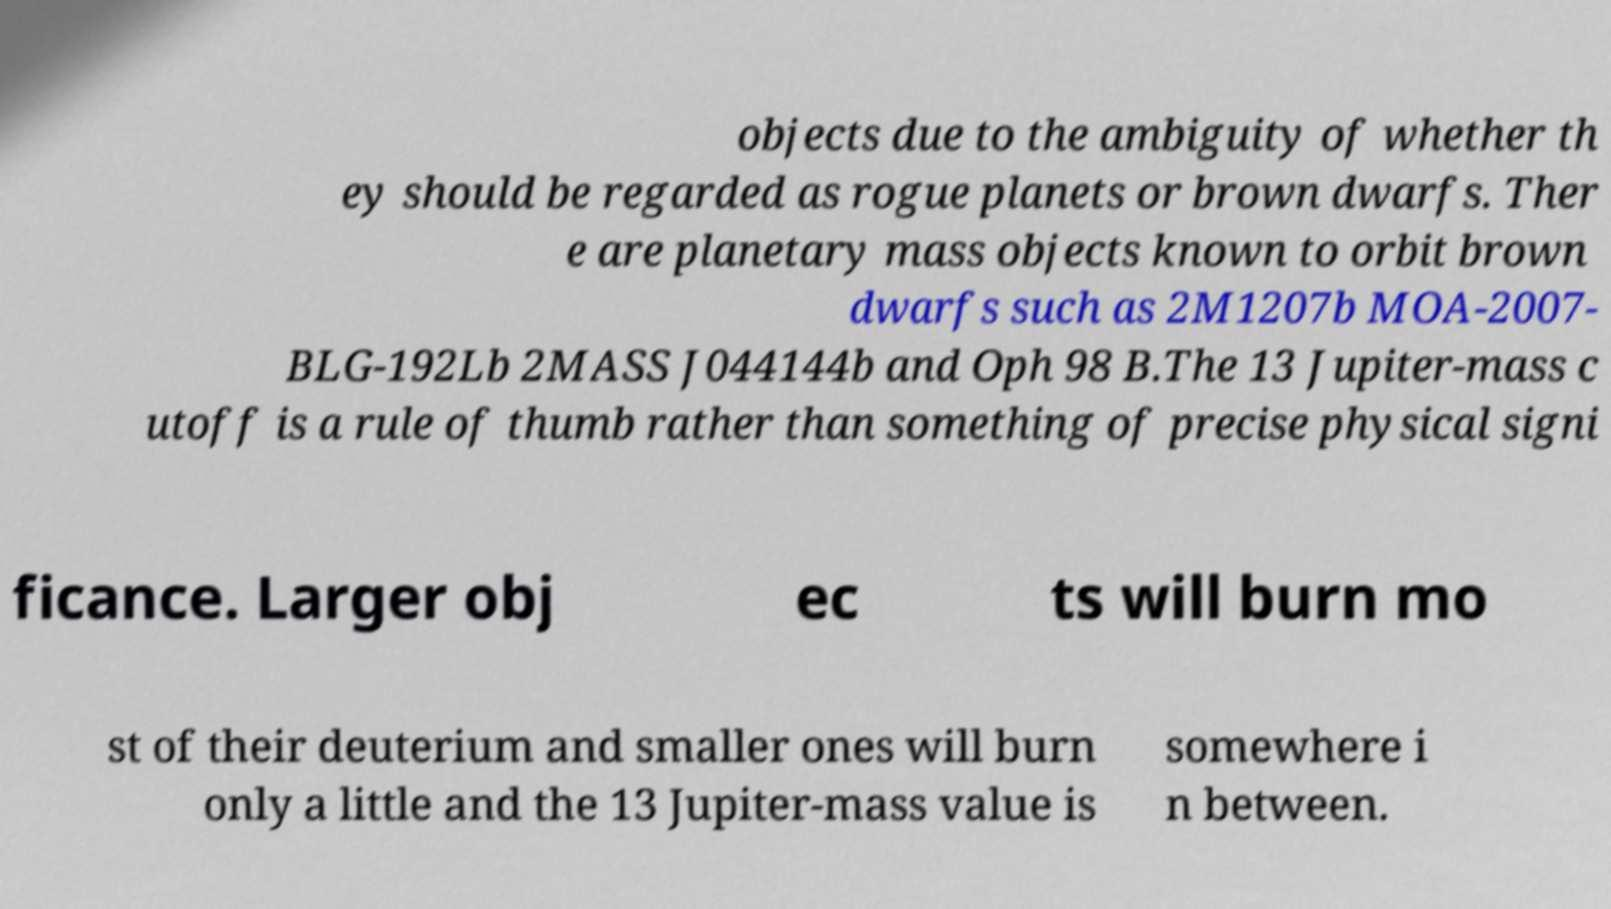Please read and relay the text visible in this image. What does it say? objects due to the ambiguity of whether th ey should be regarded as rogue planets or brown dwarfs. Ther e are planetary mass objects known to orbit brown dwarfs such as 2M1207b MOA-2007- BLG-192Lb 2MASS J044144b and Oph 98 B.The 13 Jupiter-mass c utoff is a rule of thumb rather than something of precise physical signi ficance. Larger obj ec ts will burn mo st of their deuterium and smaller ones will burn only a little and the 13 Jupiter-mass value is somewhere i n between. 